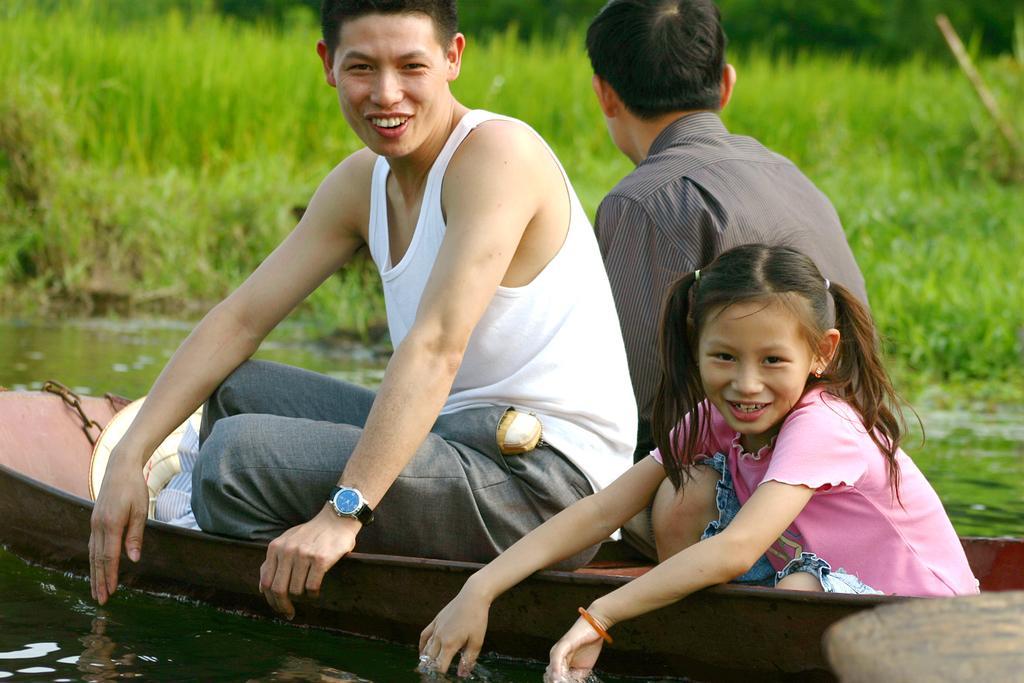Can you describe this image briefly? In this image we can see three persons sitting on a boat. And the boat is on water. In the back there is grass. One person is wearing watch. 